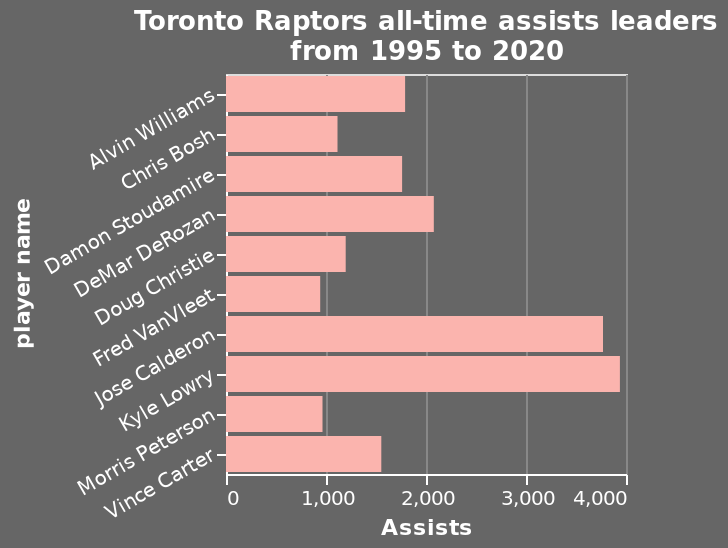<image>
Who are the two players that have considerably more assists than others?  The two players who have considerably more assists than others are not specified in the given description. Who are the all-time assists leaders for the Toronto Raptors?  The all-time assists leaders for the Toronto Raptors are a group of players who have accumulated the most assists from 1995 to 2020. 